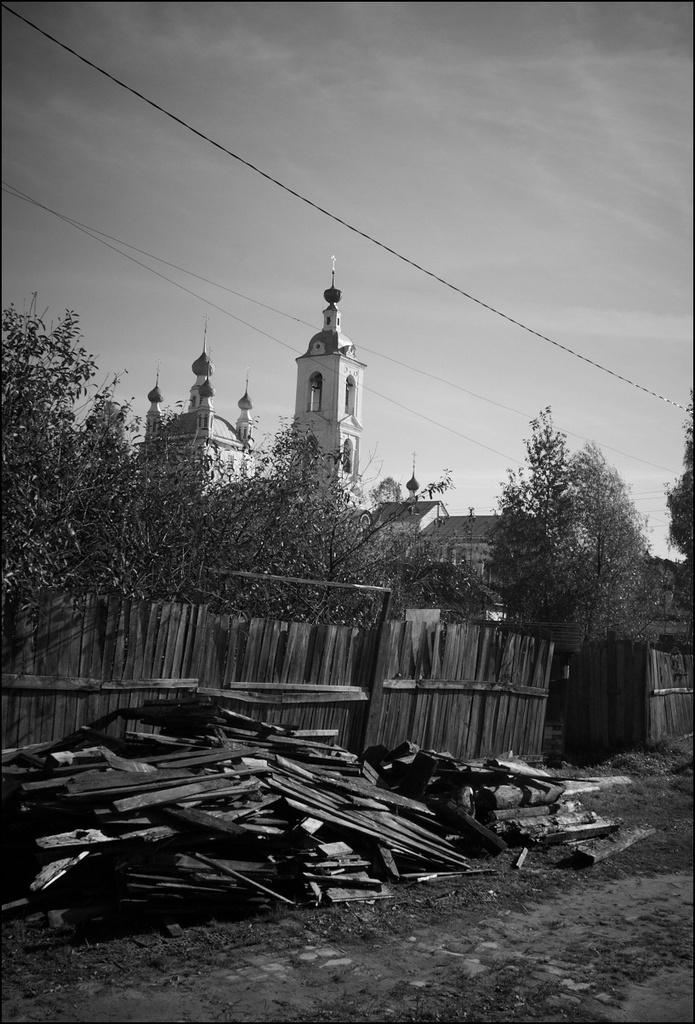What type of structure is present in the image? There is a building in the image. What other natural elements can be seen in the image? There are trees in the image. What part of the environment is visible in the image? The sky is visible in the image. What type of muscle can be seen flexing in the image? There is no muscle visible in the image; it features a building, trees, and the sky. 